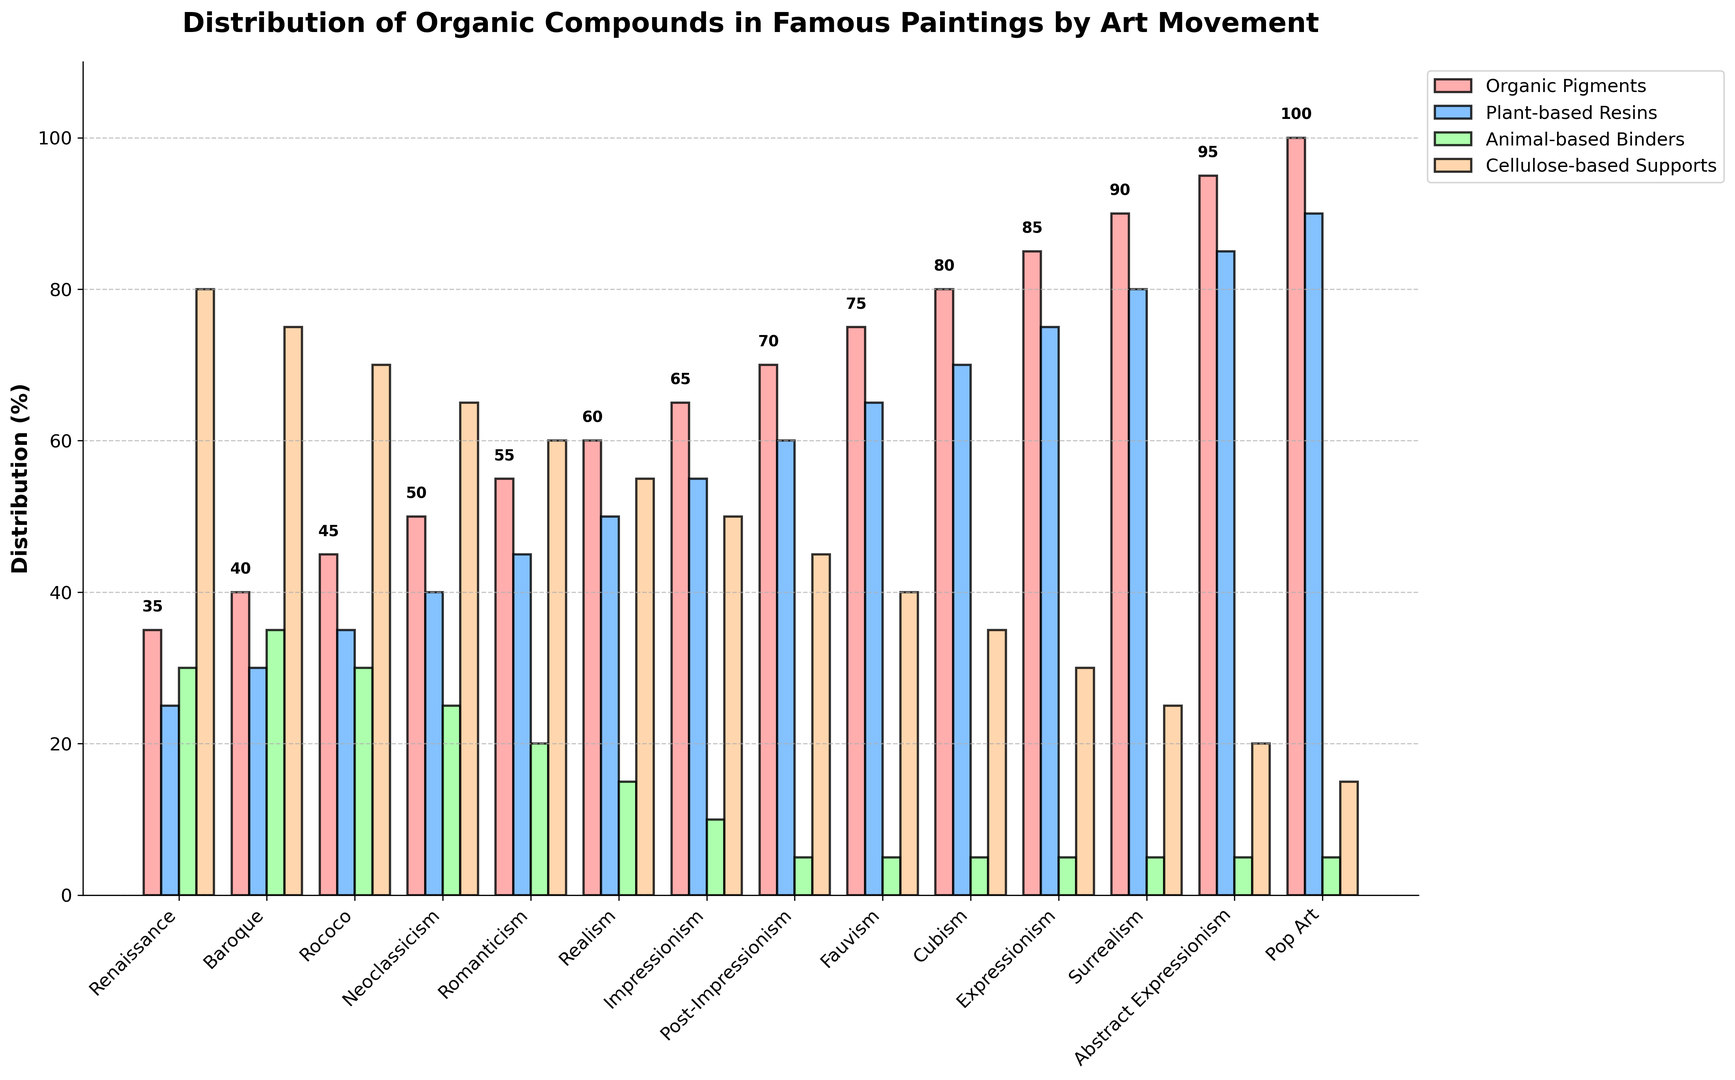What is the difference in the distribution of Organic Pigments between the Renaissance and Pop Art movements? First, locate the bars representing Organic Pigments for both Renaissance and Pop Art movements. The height of the Organic Pigments bar for Renaissance is 35%, and for Pop Art, it is 100%. Subtract the Renaissance value from the Pop Art value: 100% - 35% = 65%
Answer: 65% Between which two consecutive art movements is the largest increase in Plant-based Resins seen? Identify and compare the Plant-based Resins bars across consecutive movements. The values are: Renaissance (25%), Baroque (30%), Rococo (35%), Neoclassicism (40%), Romanticism (45%), Realism (50%), Impressionism (55%), Post-Impressionism (60%), Fauvism (65%), Cubism (70%), Expressionism (75%), Surrealism (80%), Abstract Expressionism (85%), and Pop Art (90%). The increase between each pair of consecutive movements is always 5%. However, they all are uniform increases of 5%, so any pair of consecutive movements will do
Answer: Any pair of consecutive movements (e.g., Renaissance-Baroque) Which art movement has the lowest distribution of Cellulose-based Supports and what is its value? Find the bar representing Cellulose-based Supports for all movements. The height of the Cellulose-based Supports bar is the lowest for Pop Art at 15%
Answer: Pop Art, 15% How does the distribution of Animal-based Binders differ between Renaissance and Realism movements? Locate the Animal-based Binders bars for Renaissance and Realism movements. Renaissance has 30%, while Realism has 15%. Subtract the lower value from the higher one: 30% - 15% = 15%
Answer: 15% decrease What is the average percentage of Organic Pigments for the movements from Renaissance to Realism? The values for Organic Pigments from Renaissance to Realism are 35%, 40%, 45%, 50%, 55%, 60%. Sum these: 35 + 40 + 45 + 50 + 55 + 60 = 285. Calculate the average by dividing the total by the number of movements: 285 / 6 = 47.5%
Answer: 47.5% Which two art movements have the same percentage distribution of Animal-based Binders? Identify the bars for Animal-based Binders across all movements. From the data, Cubism, Expressionism, Surrealism, Abstract Expressionism, and Pop Art all have an equal distribution at 5%
Answer: Cubism and Expressionism (could include others as well) What is the total percentage of Plant-based Resins and Cellulose-based Supports in the Impressionism movement? Locate the Plant-based Resins (55%) and Cellulose-based Supports (50%) bars for Impressionism. Sum these values: 55% + 50% = 105%
Answer: 105% Between which two art movements is there a decrease in the distribution of Cellulose-based Supports, and what is the amount of decrease? Identify when the values for Cellulose-based Supports decrease when moving from one movement to the next. A decrease can be found between Renaissance (80%) and Baroque (75%), Subtracting the respective values: 80% - 75% = 5%
Answer: Renaissance and Baroque, 5% Which color represents Animal-based Binders in the plot? Recall the colors used for Animal-based Binders in the plot. It is represented by the green-colored bar.
Answer: Green 